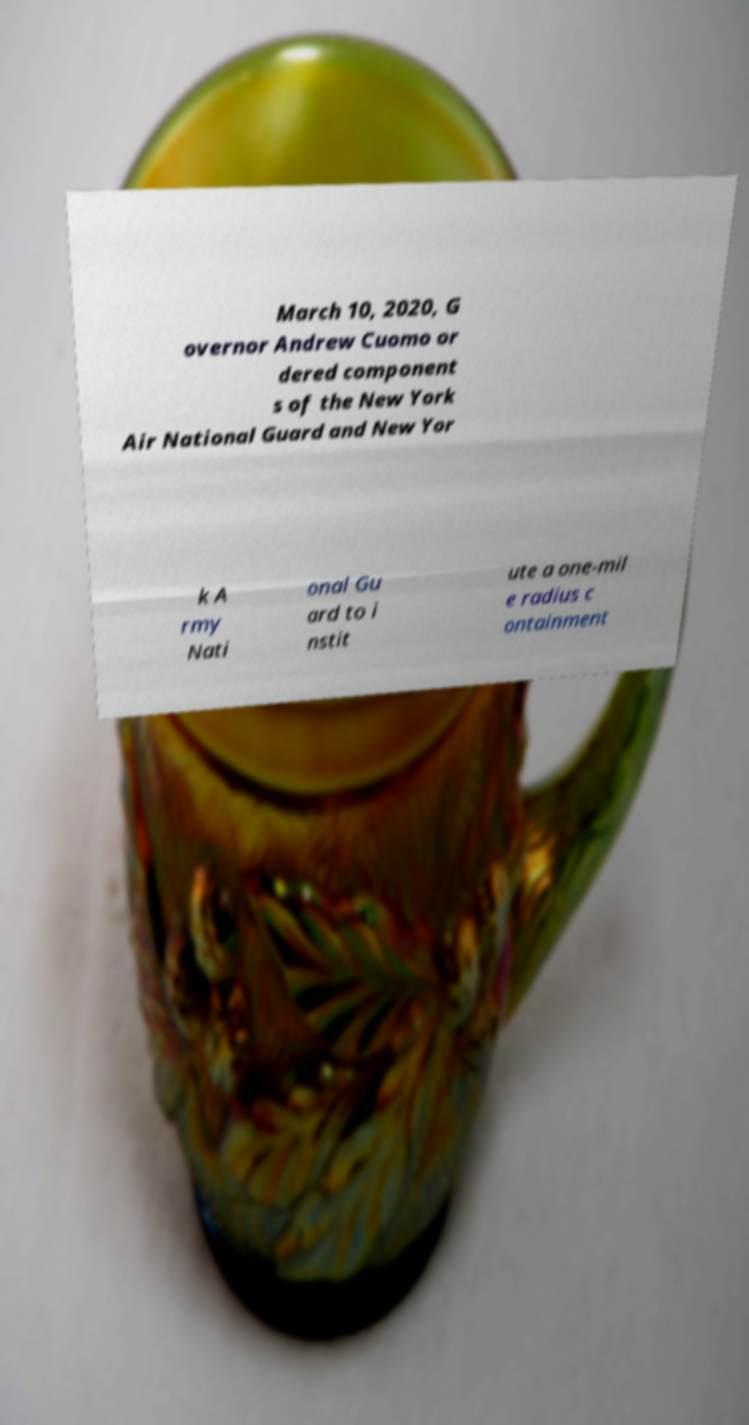There's text embedded in this image that I need extracted. Can you transcribe it verbatim? March 10, 2020, G overnor Andrew Cuomo or dered component s of the New York Air National Guard and New Yor k A rmy Nati onal Gu ard to i nstit ute a one-mil e radius c ontainment 